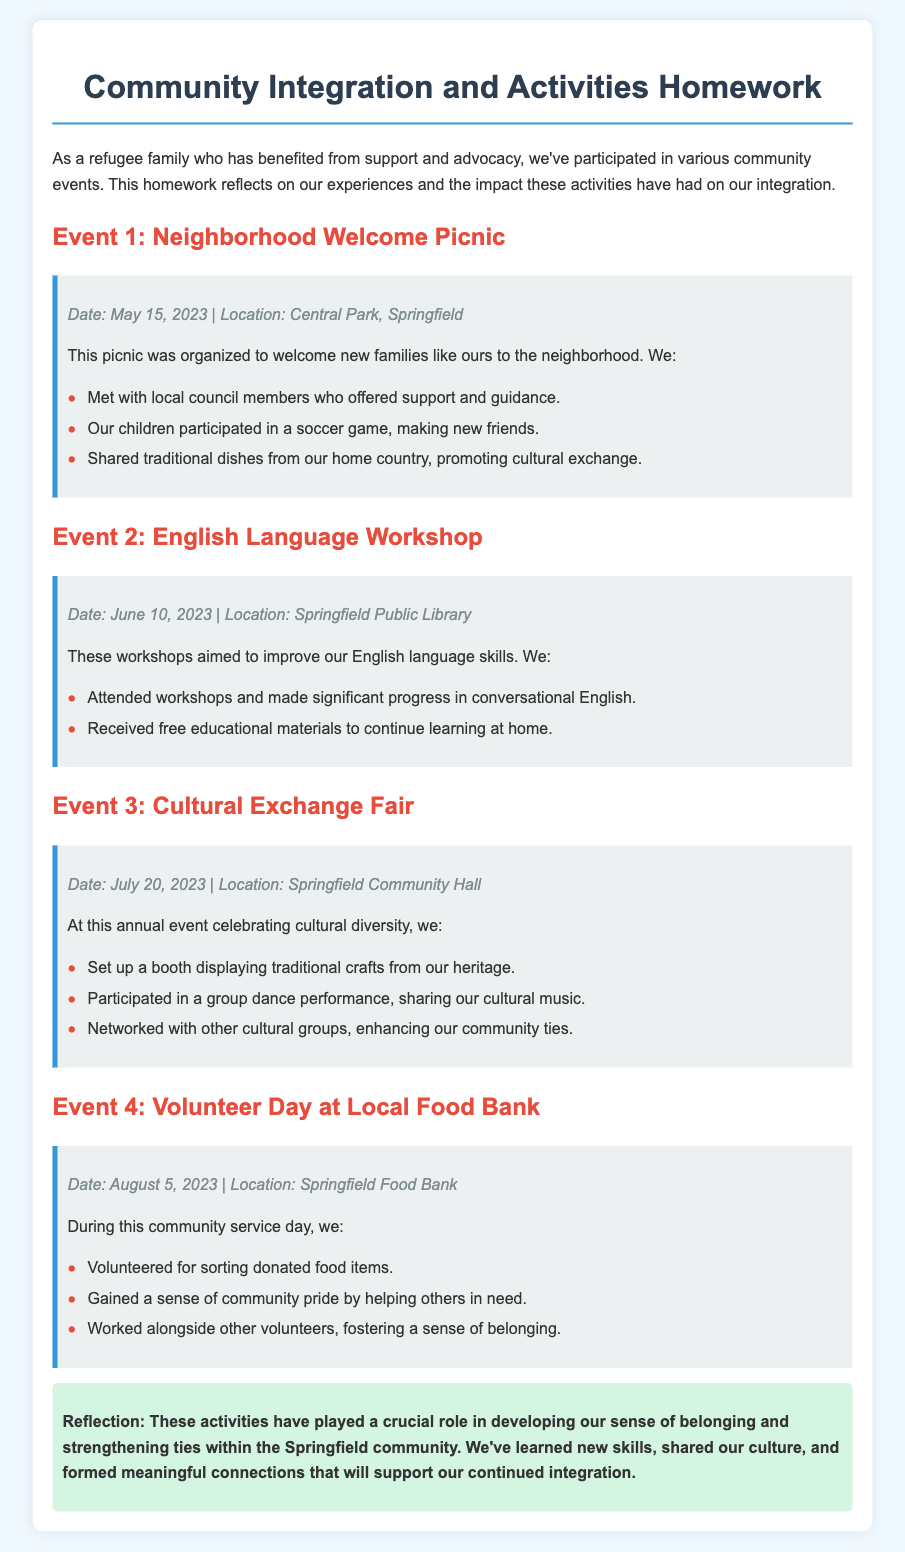What was the date of the Neighborhood Welcome Picnic? The date is mentioned in the event details of Event 1, which states May 15, 2023.
Answer: May 15, 2023 Where did the English Language Workshop take place? The location is specified in the event details of Event 2 as Springfield Public Library.
Answer: Springfield Public Library What activity did the family engage in at the Cultural Exchange Fair? The family set up a booth displaying traditional crafts from their heritage, which is listed in the activities of Event 3.
Answer: Set up a booth displaying traditional crafts How did participating in Volunteer Day make the family feel? The document states they gained a sense of community pride, indicating the positive impact of their participation in Event 4.
Answer: Sense of community pride What was the purpose of the English Language Workshop? The document mentions that the workshops aimed to improve English language skills, reflecting the educational aspect of Event 2.
Answer: Improve English language skills Which event involved local council members? At the Neighborhood Welcome Picnic, local council members offered support and guidance, as highlighted in the description of Event 1.
Answer: Neighborhood Welcome Picnic How many events are listed in the document? The document describes four distinct events, as numbered in the headings and detailed in the content.
Answer: Four What conclusion do the participants draw from their experiences? The conclusion highlights that the activities played a crucial role in developing a sense of belonging within the community.
Answer: Sense of belonging 